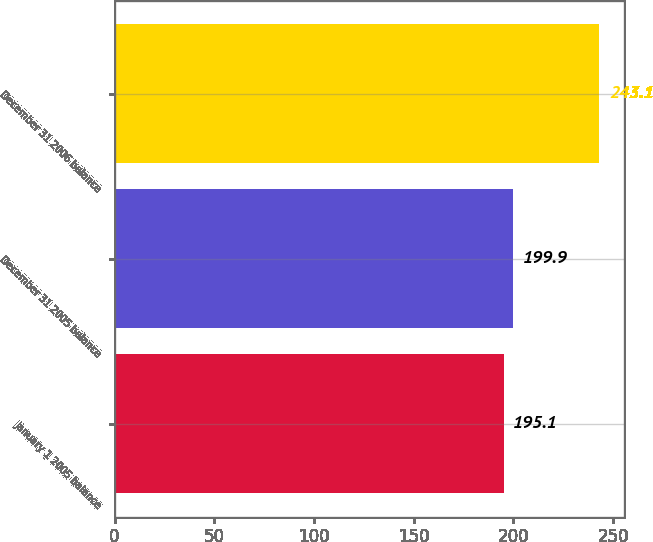Convert chart. <chart><loc_0><loc_0><loc_500><loc_500><bar_chart><fcel>January 1 2005 balance<fcel>December 31 2005 balance<fcel>December 31 2006 balance<nl><fcel>195.1<fcel>199.9<fcel>243.1<nl></chart> 